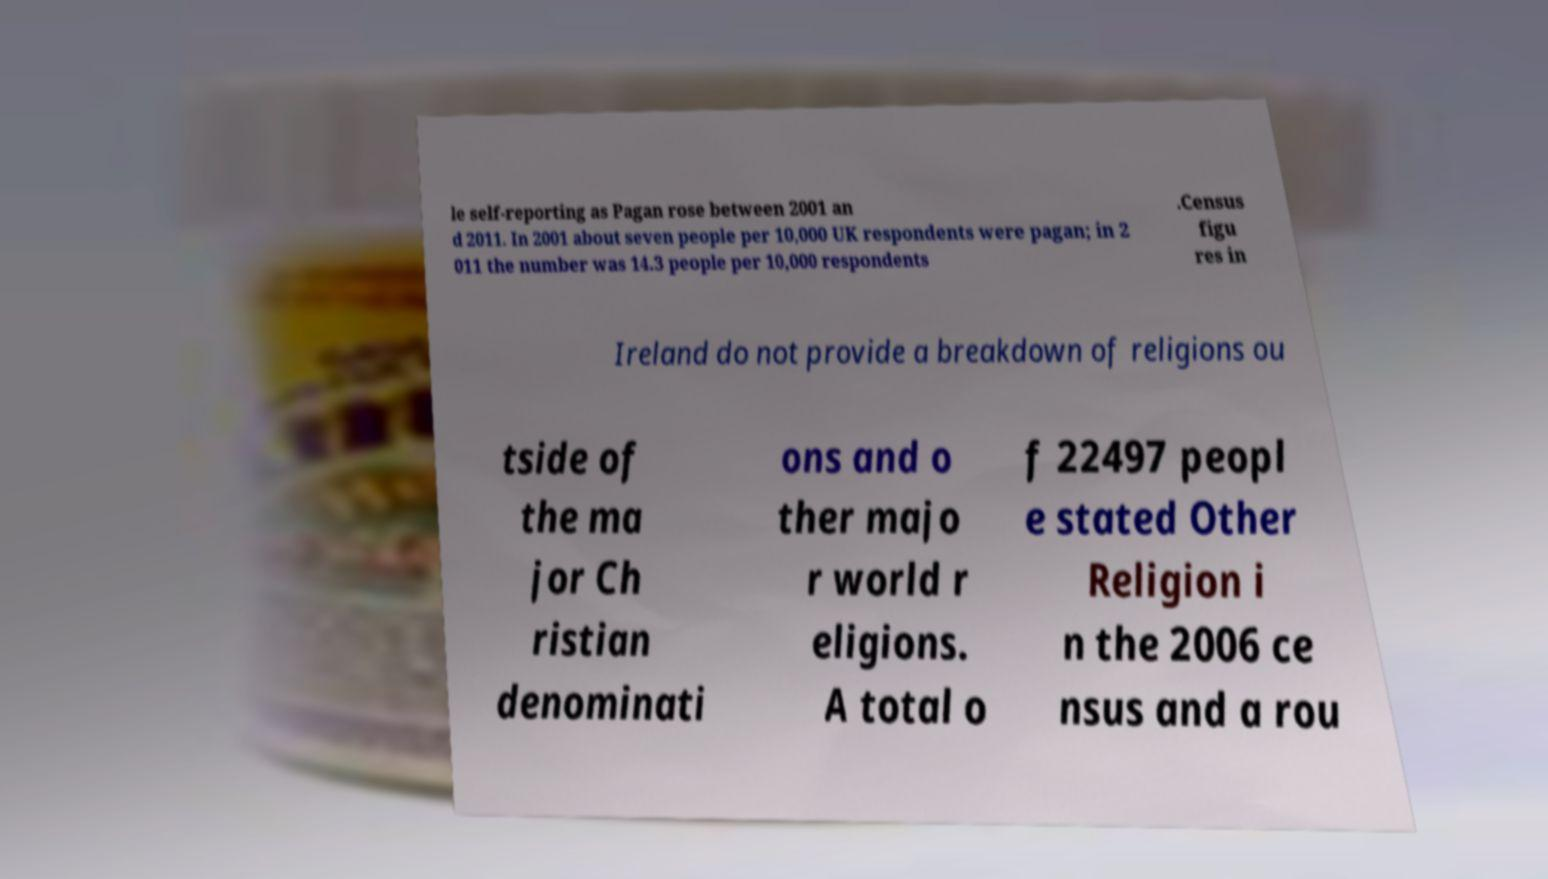Please identify and transcribe the text found in this image. le self-reporting as Pagan rose between 2001 an d 2011. In 2001 about seven people per 10,000 UK respondents were pagan; in 2 011 the number was 14.3 people per 10,000 respondents .Census figu res in Ireland do not provide a breakdown of religions ou tside of the ma jor Ch ristian denominati ons and o ther majo r world r eligions. A total o f 22497 peopl e stated Other Religion i n the 2006 ce nsus and a rou 